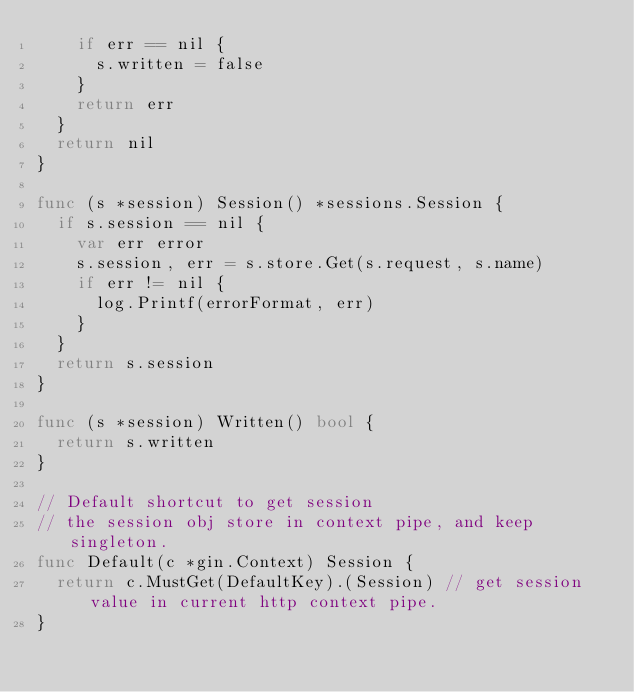<code> <loc_0><loc_0><loc_500><loc_500><_Go_>		if err == nil {
			s.written = false
		}
		return err
	}
	return nil
}

func (s *session) Session() *sessions.Session {
	if s.session == nil {
		var err error
		s.session, err = s.store.Get(s.request, s.name)
		if err != nil {
			log.Printf(errorFormat, err)
		}
	}
	return s.session
}

func (s *session) Written() bool {
	return s.written
}

// Default shortcut to get session
// the session obj store in context pipe, and keep singleton.
func Default(c *gin.Context) Session {
	return c.MustGet(DefaultKey).(Session) // get session value in current http context pipe.
}
</code> 